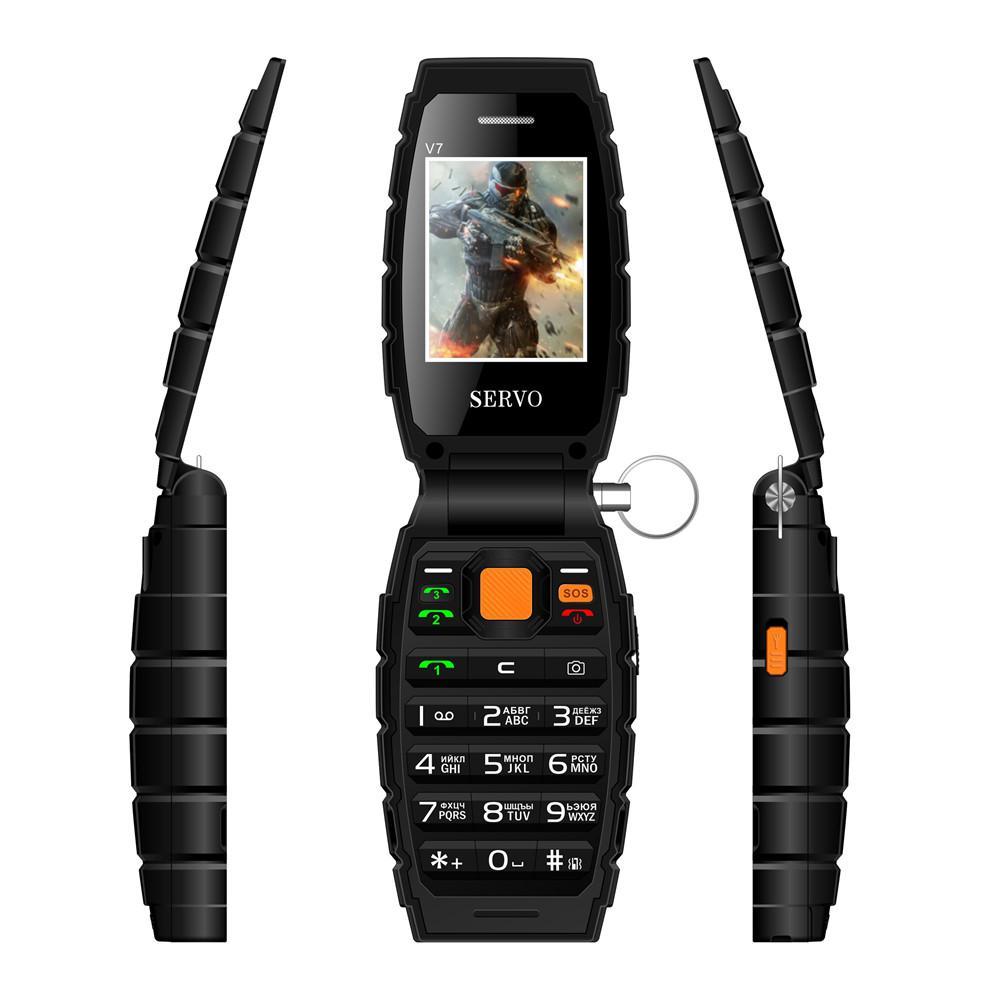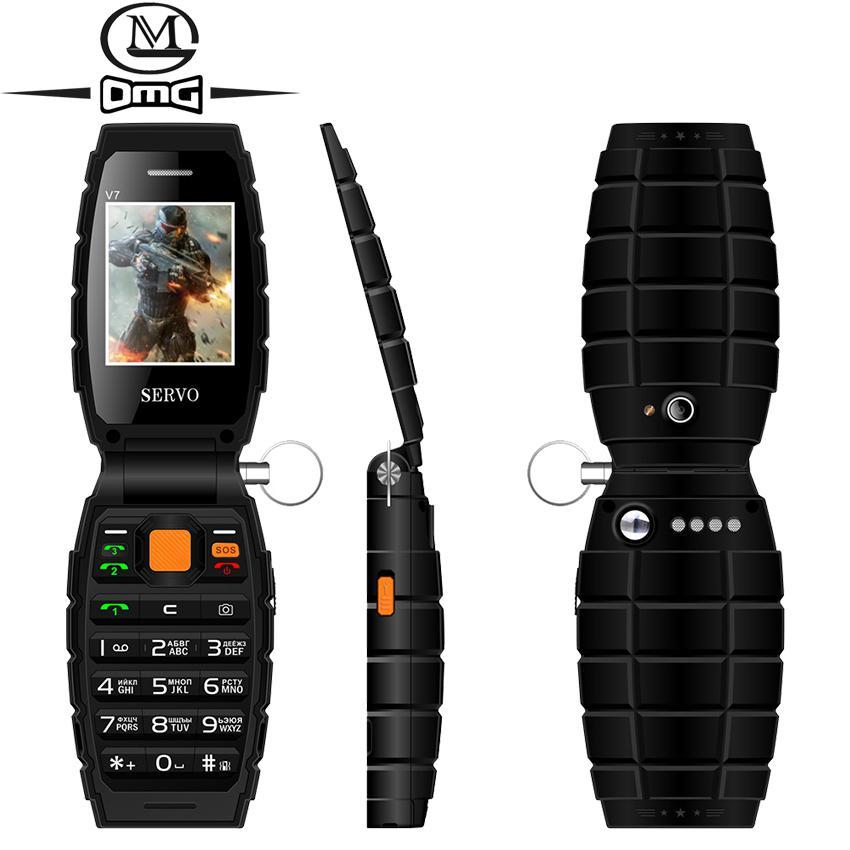The first image is the image on the left, the second image is the image on the right. Assess this claim about the two images: "At least one image shows the side profile of a phone.". Correct or not? Answer yes or no. Yes. The first image is the image on the left, the second image is the image on the right. For the images displayed, is the sentence "There is a total of six flip phones." factually correct? Answer yes or no. Yes. 